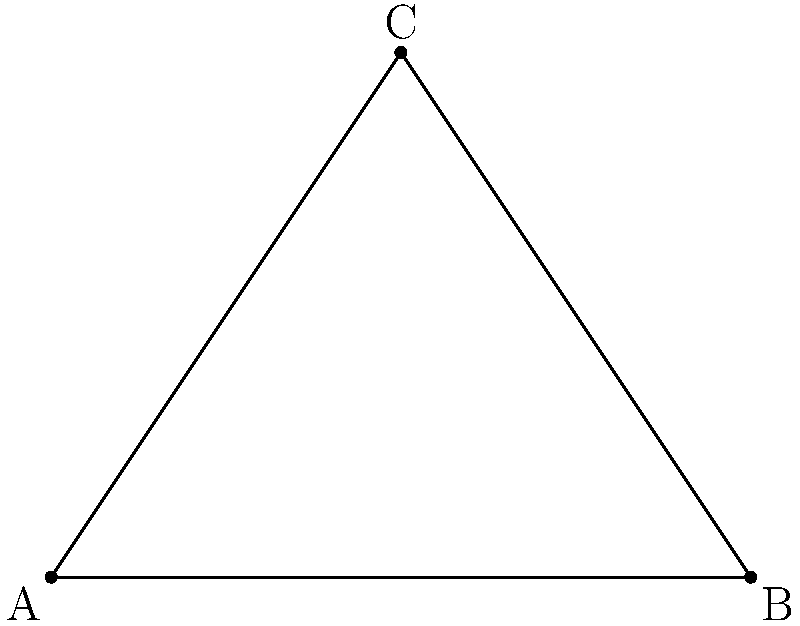In a transformer installation project, you need to connect three transformer locations A, B, and C with cables. The locations form a right-angled triangle on a 2D plane, where AB = 8 units, BC = 6 units, and AC = 10 units. What is the minimum total cable length required to connect all three locations? To find the minimum total cable length, we need to determine the shortest path that connects all three points. This is known as the Steiner tree problem for three points, which has a simple solution:

1) First, we recognize that the triangle ABC is a right-angled triangle (3-4-5 triangle scaled up by 2).

2) The optimal solution for three points is to find a point D on the hypotenuse AB such that ∠CDA = ∠CDB = 120°.

3) This point D divides the hypotenuse AB into two segments:
   AD = $x$ and DB = $y$

4) We can use the properties of 30-60-90 triangles:
   In triangle CDA: $CD = x\sqrt{3}$
   In triangle CDB: $CD = y\sqrt{3}$

5) The total length of the Steiner tree is:
   $L = x + y + x\sqrt{3} = 8 + x\sqrt{3}$

6) To find $x$, we can use the similarity of triangles CDA and CDB:
   $\frac{x}{6} = \frac{6}{y} = \frac{6}{8-x}$

7) Solving this equation:
   $x^2 - 8x + 24 = 0$
   $(x - 4)^2 = 8$
   $x = 4 + 2\sqrt{2}$

8) Substituting back into the length formula:
   $L = 8 + (4 + 2\sqrt{2})\sqrt{3}$
   $L = 8 + 4\sqrt{3} + 2\sqrt{6}$

Therefore, the minimum total cable length is $8 + 4\sqrt{3} + 2\sqrt{6}$ units.
Answer: $8 + 4\sqrt{3} + 2\sqrt{6}$ units 